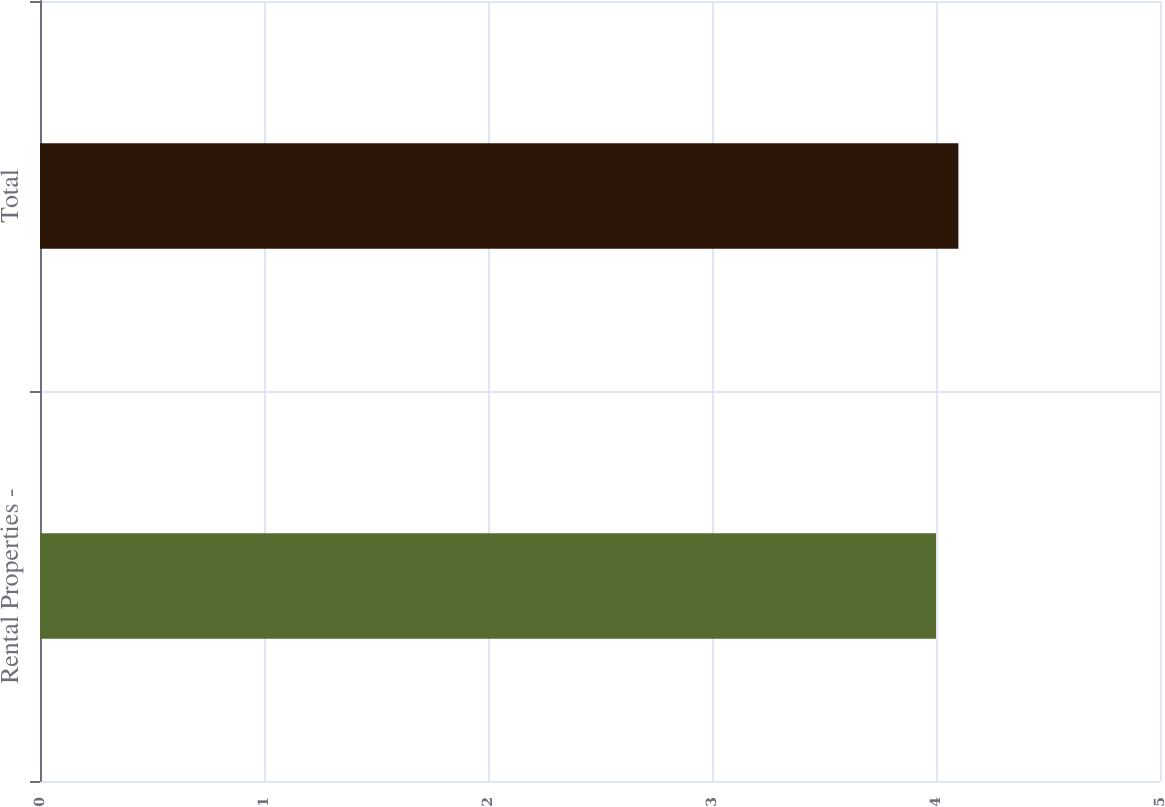Convert chart to OTSL. <chart><loc_0><loc_0><loc_500><loc_500><bar_chart><fcel>Rental Properties -<fcel>Total<nl><fcel>4<fcel>4.1<nl></chart> 